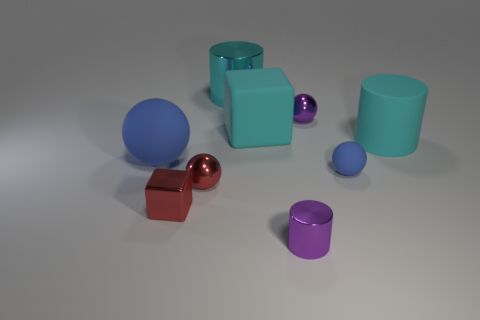Subtract all large matte balls. How many balls are left? 3 Subtract 1 balls. How many balls are left? 3 Subtract all purple balls. How many balls are left? 3 Subtract all cubes. How many objects are left? 7 Subtract all green cylinders. Subtract all red balls. How many cylinders are left? 3 Add 6 cyan metal objects. How many cyan metal objects are left? 7 Add 9 big yellow metallic cubes. How many big yellow metallic cubes exist? 9 Subtract 1 red spheres. How many objects are left? 8 Subtract all rubber blocks. Subtract all green cubes. How many objects are left? 8 